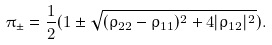Convert formula to latex. <formula><loc_0><loc_0><loc_500><loc_500>\pi _ { \pm } = \frac { 1 } { 2 } ( 1 \pm \sqrt { ( \rho _ { 2 2 } - \rho _ { 1 1 } ) ^ { 2 } + 4 | \rho _ { 1 2 } | ^ { 2 } } ) .</formula> 